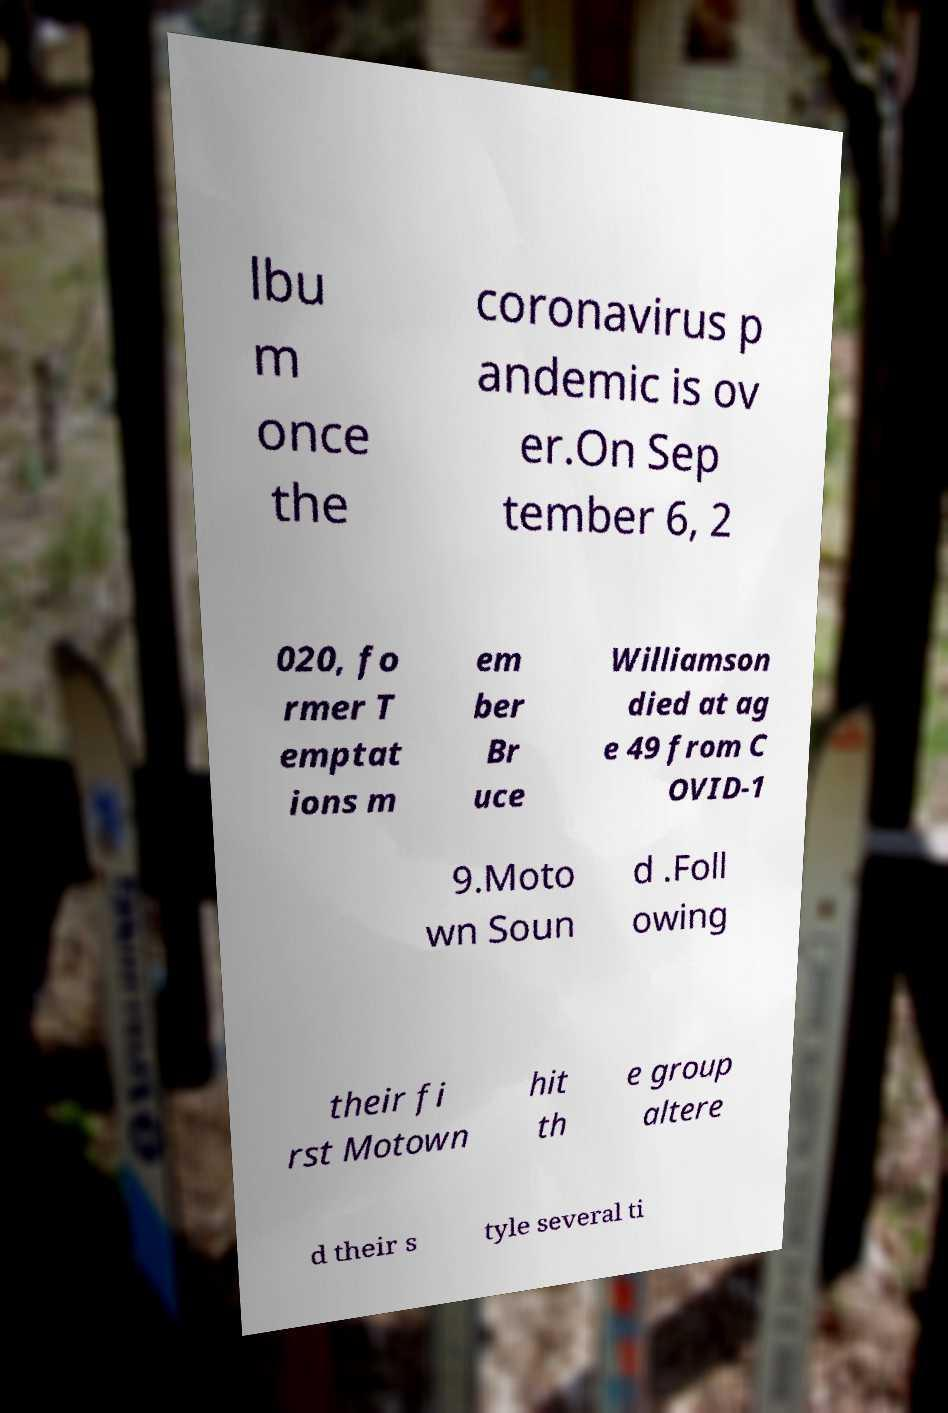Could you assist in decoding the text presented in this image and type it out clearly? lbu m once the coronavirus p andemic is ov er.On Sep tember 6, 2 020, fo rmer T emptat ions m em ber Br uce Williamson died at ag e 49 from C OVID-1 9.Moto wn Soun d .Foll owing their fi rst Motown hit th e group altere d their s tyle several ti 